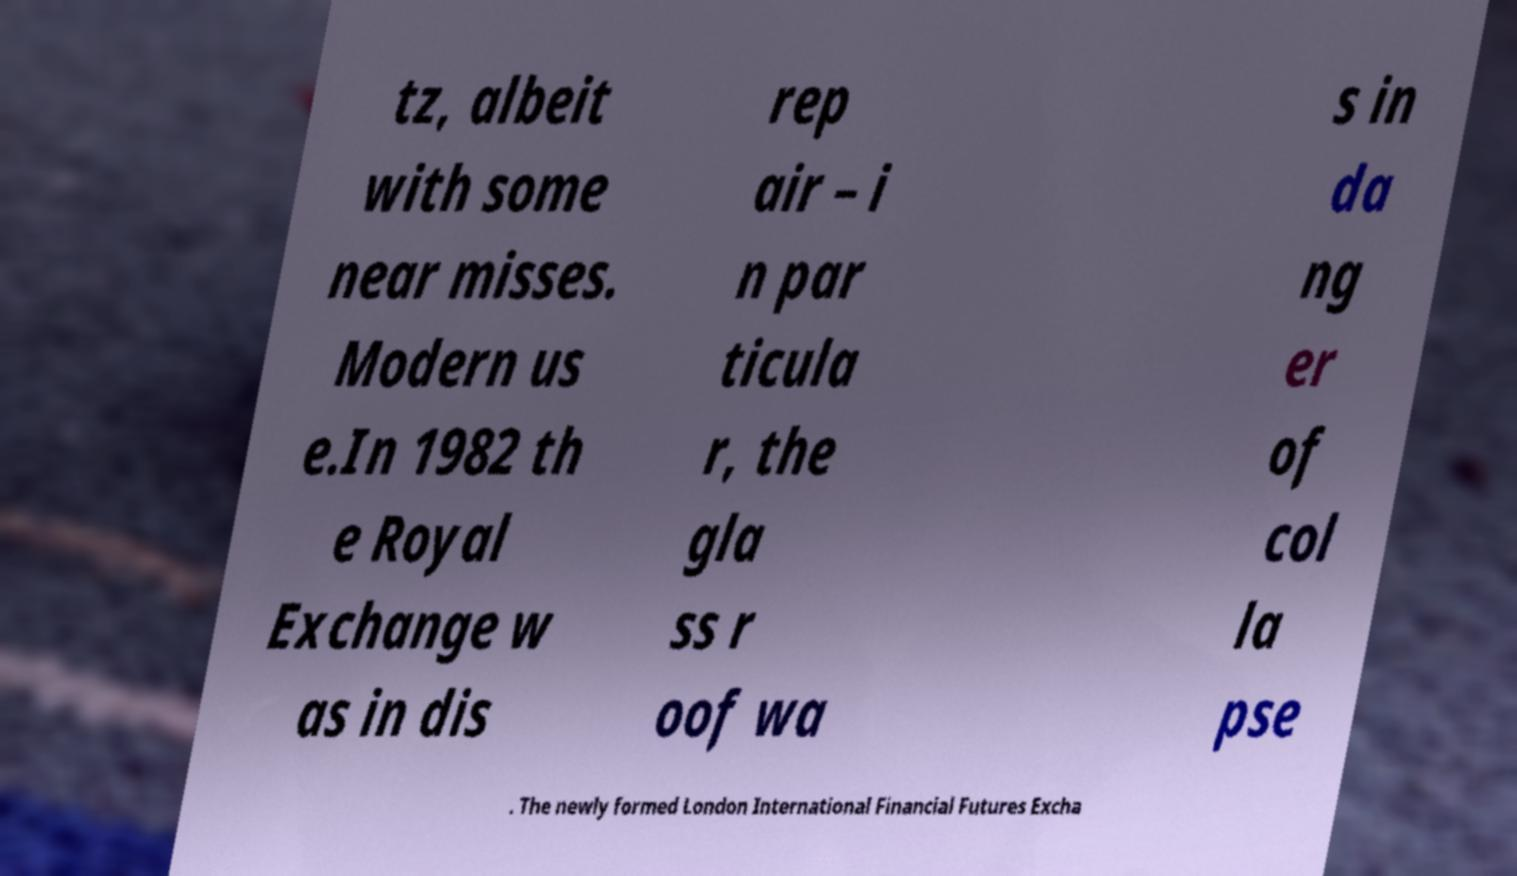There's text embedded in this image that I need extracted. Can you transcribe it verbatim? tz, albeit with some near misses. Modern us e.In 1982 th e Royal Exchange w as in dis rep air – i n par ticula r, the gla ss r oof wa s in da ng er of col la pse . The newly formed London International Financial Futures Excha 